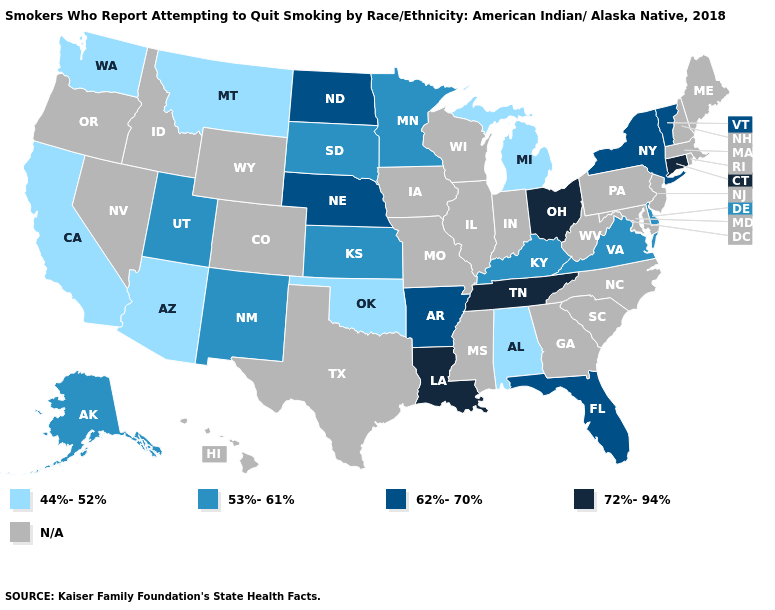What is the value of Mississippi?
Write a very short answer. N/A. What is the value of Vermont?
Write a very short answer. 62%-70%. What is the highest value in states that border Florida?
Short answer required. 44%-52%. What is the value of Idaho?
Concise answer only. N/A. Which states have the lowest value in the USA?
Be succinct. Alabama, Arizona, California, Michigan, Montana, Oklahoma, Washington. Name the states that have a value in the range 62%-70%?
Short answer required. Arkansas, Florida, Nebraska, New York, North Dakota, Vermont. Does Delaware have the lowest value in the South?
Keep it brief. No. Is the legend a continuous bar?
Short answer required. No. Name the states that have a value in the range 62%-70%?
Quick response, please. Arkansas, Florida, Nebraska, New York, North Dakota, Vermont. Does Nebraska have the lowest value in the USA?
Answer briefly. No. What is the value of West Virginia?
Short answer required. N/A. Name the states that have a value in the range 72%-94%?
Concise answer only. Connecticut, Louisiana, Ohio, Tennessee. Name the states that have a value in the range N/A?
Quick response, please. Colorado, Georgia, Hawaii, Idaho, Illinois, Indiana, Iowa, Maine, Maryland, Massachusetts, Mississippi, Missouri, Nevada, New Hampshire, New Jersey, North Carolina, Oregon, Pennsylvania, Rhode Island, South Carolina, Texas, West Virginia, Wisconsin, Wyoming. Which states hav the highest value in the Northeast?
Answer briefly. Connecticut. 